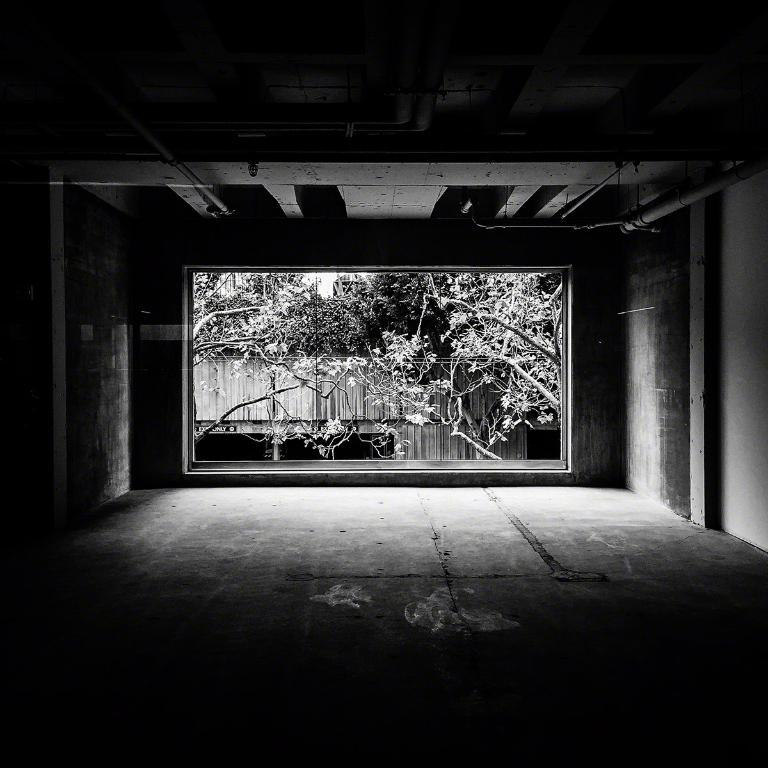What is the color scheme of the image? The image is black and white. What can be seen in the middle of the image? There are trees in the middle of the image. How many stars are visible in the image? There are no stars visible in the image, as it is a black and white image with trees in the middle. Are there any brothers present in the image? There is no mention of brothers or any people in the image, only trees. 